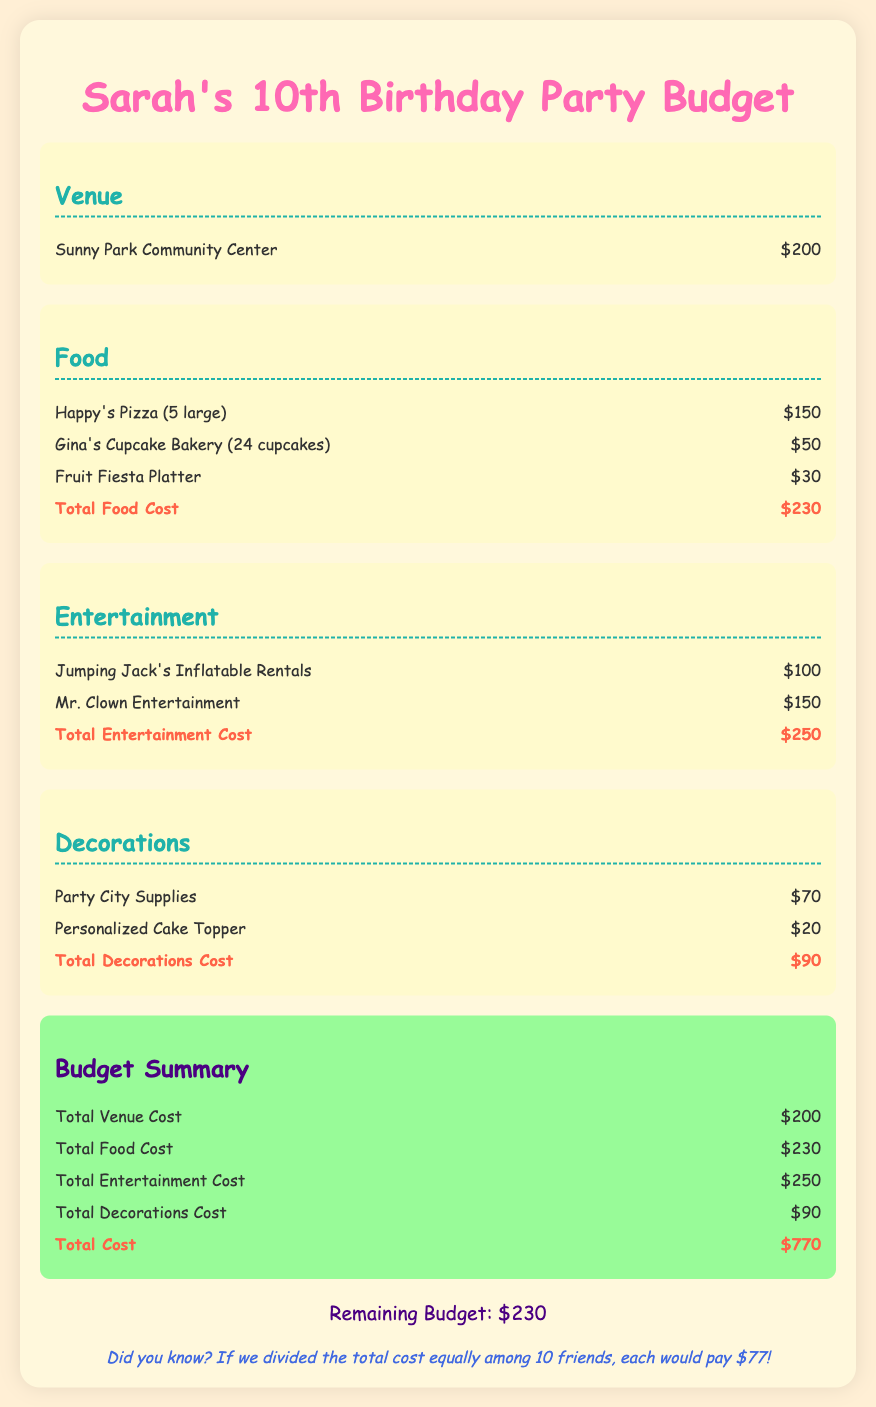What is the total venue cost? The total venue cost is listed in the budget and is $200.
Answer: $200 How much did the food cost? The total cost of food is provided in the food section and is $230.
Answer: $230 What is the total entertainment cost? The total entertainment cost is shown in the entertainment section and amounts to $250.
Answer: $250 What are the two main items listed under decorations? The decorations section includes Party City Supplies and a Personalized Cake Topper.
Answer: Party City Supplies, Personalized Cake Topper What is the total cost of the party? The overall total cost of the party is summarized at the end and is $770.
Answer: $770 How much money is remaining in the budget? The remaining budget is clearly stated at the end and is $230.
Answer: $230 What type of venue is being rented? The venue specified for the party is the Sunny Park Community Center.
Answer: Sunny Park Community Center How many cupcakes are ordered? The document states that 24 cupcakes are ordered from Gina's Cupcake Bakery.
Answer: 24 cupcakes What is the total decoration cost? The total cost for decorations is provided in the decorations section, which is $90.
Answer: $90 